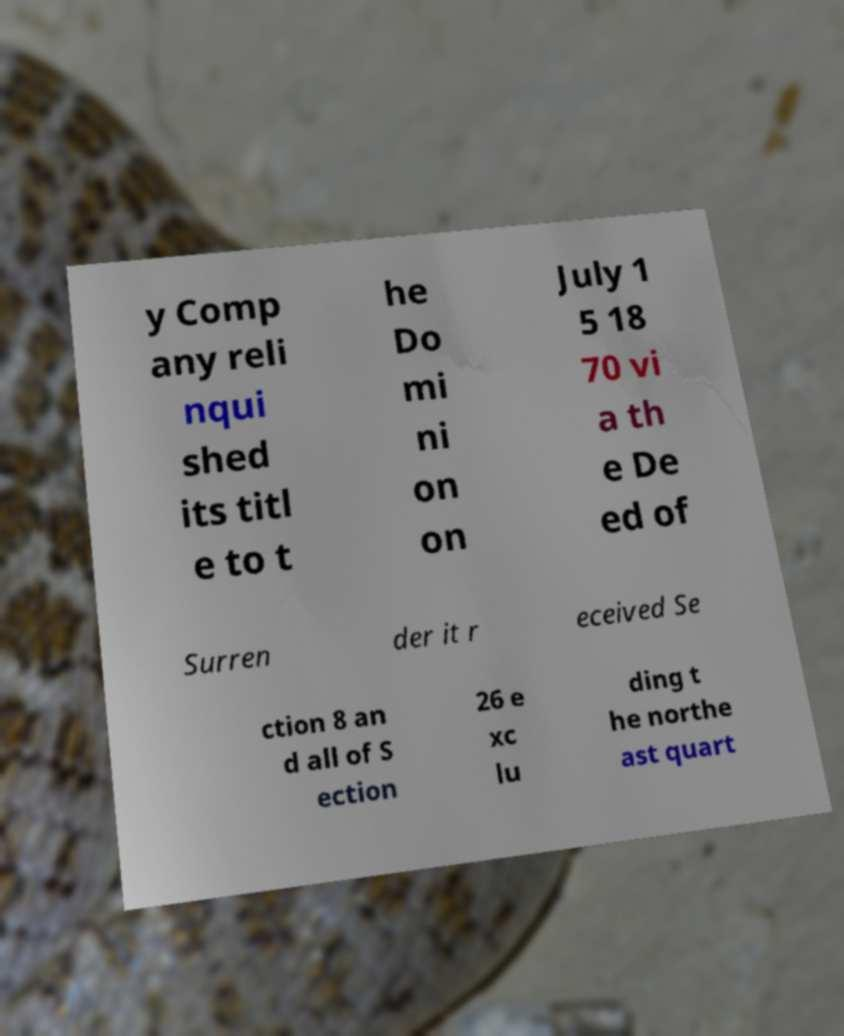Could you assist in decoding the text presented in this image and type it out clearly? y Comp any reli nqui shed its titl e to t he Do mi ni on on July 1 5 18 70 vi a th e De ed of Surren der it r eceived Se ction 8 an d all of S ection 26 e xc lu ding t he northe ast quart 